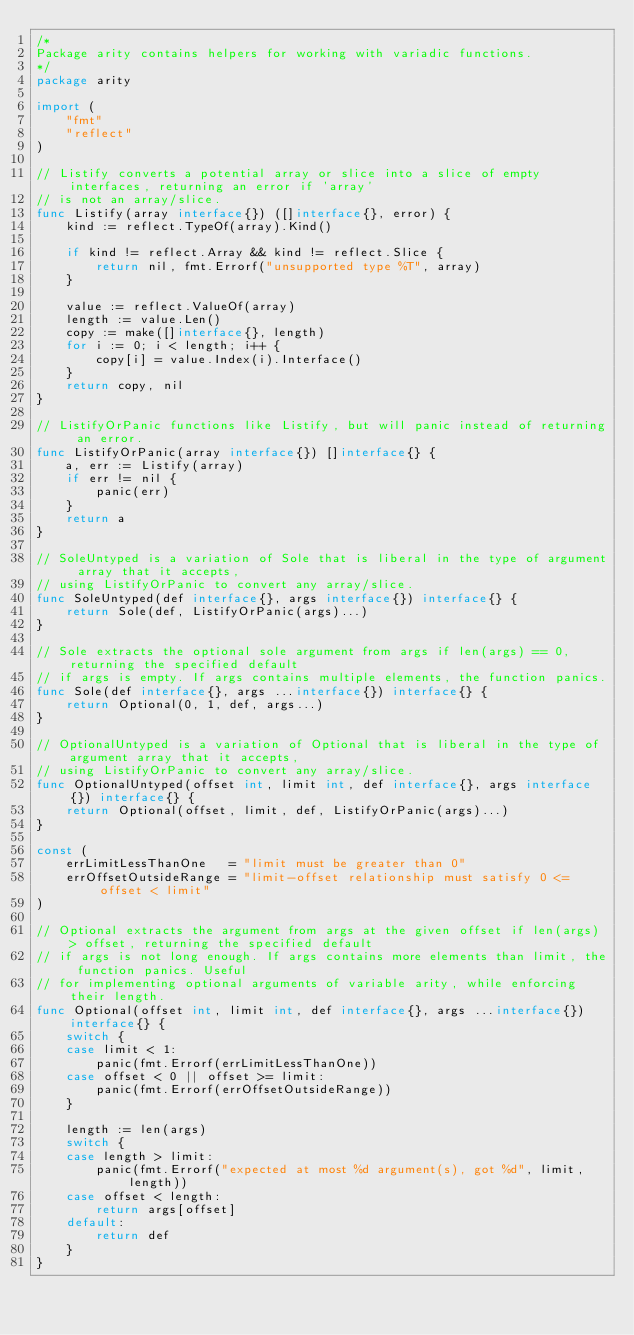<code> <loc_0><loc_0><loc_500><loc_500><_Go_>/*
Package arity contains helpers for working with variadic functions.
*/
package arity

import (
	"fmt"
	"reflect"
)

// Listify converts a potential array or slice into a slice of empty interfaces, returning an error if 'array'
// is not an array/slice.
func Listify(array interface{}) ([]interface{}, error) {
	kind := reflect.TypeOf(array).Kind()

	if kind != reflect.Array && kind != reflect.Slice {
		return nil, fmt.Errorf("unsupported type %T", array)
	}

	value := reflect.ValueOf(array)
	length := value.Len()
	copy := make([]interface{}, length)
	for i := 0; i < length; i++ {
		copy[i] = value.Index(i).Interface()
	}
	return copy, nil
}

// ListifyOrPanic functions like Listify, but will panic instead of returning an error.
func ListifyOrPanic(array interface{}) []interface{} {
	a, err := Listify(array)
	if err != nil {
		panic(err)
	}
	return a
}

// SoleUntyped is a variation of Sole that is liberal in the type of argument array that it accepts,
// using ListifyOrPanic to convert any array/slice.
func SoleUntyped(def interface{}, args interface{}) interface{} {
	return Sole(def, ListifyOrPanic(args)...)
}

// Sole extracts the optional sole argument from args if len(args) == 0, returning the specified default
// if args is empty. If args contains multiple elements, the function panics.
func Sole(def interface{}, args ...interface{}) interface{} {
	return Optional(0, 1, def, args...)
}

// OptionalUntyped is a variation of Optional that is liberal in the type of argument array that it accepts,
// using ListifyOrPanic to convert any array/slice.
func OptionalUntyped(offset int, limit int, def interface{}, args interface{}) interface{} {
	return Optional(offset, limit, def, ListifyOrPanic(args)...)
}

const (
	errLimitLessThanOne   = "limit must be greater than 0"
	errOffsetOutsideRange = "limit-offset relationship must satisfy 0 <= offset < limit"
)

// Optional extracts the argument from args at the given offset if len(args) > offset, returning the specified default
// if args is not long enough. If args contains more elements than limit, the function panics. Useful
// for implementing optional arguments of variable arity, while enforcing their length.
func Optional(offset int, limit int, def interface{}, args ...interface{}) interface{} {
	switch {
	case limit < 1:
		panic(fmt.Errorf(errLimitLessThanOne))
	case offset < 0 || offset >= limit:
		panic(fmt.Errorf(errOffsetOutsideRange))
	}

	length := len(args)
	switch {
	case length > limit:
		panic(fmt.Errorf("expected at most %d argument(s), got %d", limit, length))
	case offset < length:
		return args[offset]
	default:
		return def
	}
}
</code> 